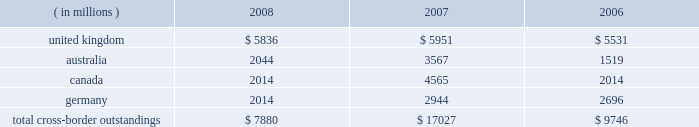Cross-border outstandings cross-border outstandings , as defined by bank regulatory rules , are amounts payable to state street by residents of foreign countries , regardless of the currency in which the claim is denominated , and local country claims in excess of local country obligations .
These cross-border outstandings consist primarily of deposits with banks , loan and lease financing and investment securities .
In addition to credit risk , cross-border outstandings have the risk that , as a result of political or economic conditions in a country , borrowers may be unable to meet their contractual repayment obligations of principal and/or interest when due because of the unavailability of , or restrictions on , foreign exchange needed by borrowers to repay their obligations .
Cross-border outstandings to countries in which we do business which amounted to at least 1% ( 1 % ) of our consolidated total assets were as follows as of december 31: .
The total cross-border outstandings presented in the table represented 5% ( 5 % ) , 12% ( 12 % ) and 9% ( 9 % ) of our consolidated total assets as of december 31 , 2008 , 2007 and 2006 , respectively .
Aggregate cross-border outstandings to countries which totaled between .75% ( .75 % ) and 1% ( 1 % ) of our consolidated total assets at december 31 , 2008 amounted to $ 3.45 billion ( canada and germany ) .
There were no cross-border outstandings to countries which totaled between .75% ( .75 % ) and 1% ( 1 % ) of our consolidated total assets as of december 31 , 2007 .
Aggregate cross-border outstandings to countries which totaled between .75% ( .75 % ) and 1% ( 1 % ) of our consolidated total assets at december 31 , 2006 amounted to $ 1.05 billion ( canada ) .
Capital regulatory and economic capital management both use key metrics evaluated by management to assess whether our actual level of capital is commensurate with our risk profile , is in compliance with all regulatory requirements , and is sufficient to provide us with the financial flexibility to undertake future strategic business initiatives .
Regulatory capital our objective with respect to regulatory capital management is to maintain a strong capital base in order to provide financial flexibility for our business needs , including funding corporate growth and supporting customers 2019 cash management needs , and to provide protection against loss to depositors and creditors .
We strive to maintain an optimal level of capital , commensurate with our risk profile , on which an attractive return to shareholders will be realized over both the short and long term , while protecting our obligations to depositors and creditors and satisfying regulatory requirements .
Our capital management process focuses on our risk exposures , our capital position relative to our peers , regulatory capital requirements and the evaluations of the major independent credit rating agencies that assign ratings to our public debt .
Our capital committee , working in conjunction with our asset and liability committee , referred to as alco , oversees the management of regulatory capital , and is responsible for ensuring capital adequacy with respect to regulatory requirements , internal targets and the expectations of the major independent credit rating agencies .
The primary regulator of both state street and state street bank for regulatory capital purposes is the federal reserve .
Both state street and state street bank are subject to the minimum capital requirements established by the federal reserve and defined in the federal deposit insurance corporation improvement act .
In 2007 , what percent of cross border outstandings were in the united kingdom? 
Computations: (5951 / 17027)
Answer: 0.3495. 